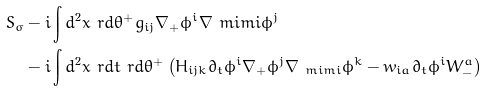Convert formula to latex. <formula><loc_0><loc_0><loc_500><loc_500>S _ { \sigma } & - i \int d { ^ { 2 } x \ r d \theta ^ { + } } g _ { i j } \nabla _ { + } \phi ^ { i } \nabla _ { \ } m i m i \phi ^ { j } \\ & - i \int d { ^ { 2 } x \ r d t \ r d \theta ^ { + } } \left ( H _ { i j k } \partial _ { t } \phi ^ { i } \nabla _ { + } \phi ^ { j } \nabla _ { \ m i m i } \phi ^ { k } - w _ { i a } \partial _ { t } \phi ^ { i } W _ { - } ^ { a } \right )</formula> 